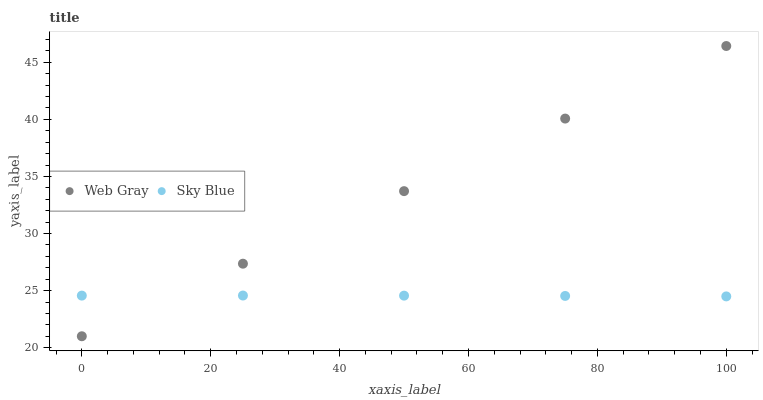Does Sky Blue have the minimum area under the curve?
Answer yes or no. Yes. Does Web Gray have the maximum area under the curve?
Answer yes or no. Yes. Does Web Gray have the minimum area under the curve?
Answer yes or no. No. Is Web Gray the smoothest?
Answer yes or no. Yes. Is Sky Blue the roughest?
Answer yes or no. Yes. Is Web Gray the roughest?
Answer yes or no. No. Does Web Gray have the lowest value?
Answer yes or no. Yes. Does Web Gray have the highest value?
Answer yes or no. Yes. Does Sky Blue intersect Web Gray?
Answer yes or no. Yes. Is Sky Blue less than Web Gray?
Answer yes or no. No. Is Sky Blue greater than Web Gray?
Answer yes or no. No. 